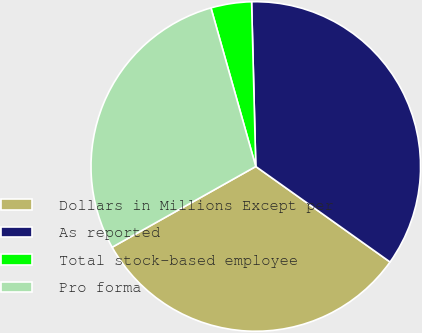Convert chart to OTSL. <chart><loc_0><loc_0><loc_500><loc_500><pie_chart><fcel>Dollars in Millions Except per<fcel>As reported<fcel>Total stock-based employee<fcel>Pro forma<nl><fcel>32.01%<fcel>35.25%<fcel>3.98%<fcel>28.77%<nl></chart> 